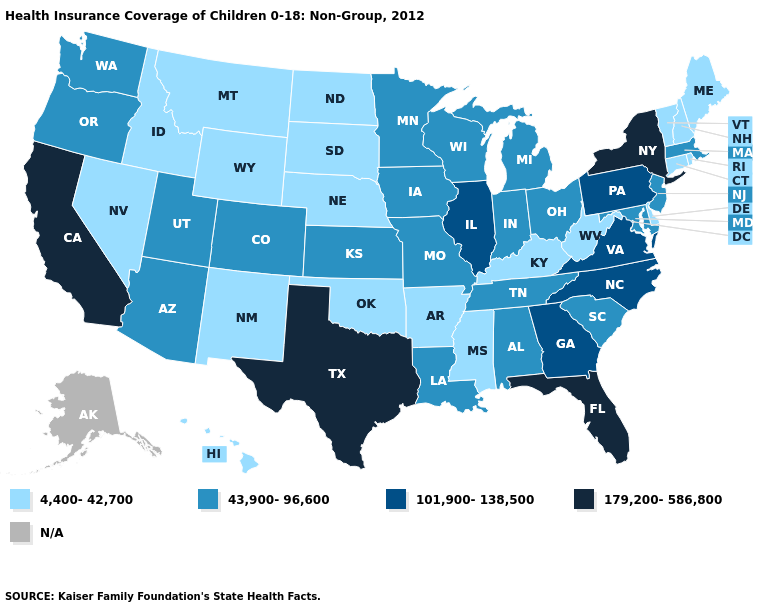Name the states that have a value in the range 4,400-42,700?
Short answer required. Arkansas, Connecticut, Delaware, Hawaii, Idaho, Kentucky, Maine, Mississippi, Montana, Nebraska, Nevada, New Hampshire, New Mexico, North Dakota, Oklahoma, Rhode Island, South Dakota, Vermont, West Virginia, Wyoming. Name the states that have a value in the range 43,900-96,600?
Concise answer only. Alabama, Arizona, Colorado, Indiana, Iowa, Kansas, Louisiana, Maryland, Massachusetts, Michigan, Minnesota, Missouri, New Jersey, Ohio, Oregon, South Carolina, Tennessee, Utah, Washington, Wisconsin. Which states hav the highest value in the Northeast?
Write a very short answer. New York. What is the lowest value in the USA?
Keep it brief. 4,400-42,700. What is the lowest value in the South?
Write a very short answer. 4,400-42,700. Name the states that have a value in the range 4,400-42,700?
Be succinct. Arkansas, Connecticut, Delaware, Hawaii, Idaho, Kentucky, Maine, Mississippi, Montana, Nebraska, Nevada, New Hampshire, New Mexico, North Dakota, Oklahoma, Rhode Island, South Dakota, Vermont, West Virginia, Wyoming. Name the states that have a value in the range 101,900-138,500?
Write a very short answer. Georgia, Illinois, North Carolina, Pennsylvania, Virginia. Is the legend a continuous bar?
Give a very brief answer. No. Does the map have missing data?
Write a very short answer. Yes. Name the states that have a value in the range 43,900-96,600?
Short answer required. Alabama, Arizona, Colorado, Indiana, Iowa, Kansas, Louisiana, Maryland, Massachusetts, Michigan, Minnesota, Missouri, New Jersey, Ohio, Oregon, South Carolina, Tennessee, Utah, Washington, Wisconsin. Name the states that have a value in the range 43,900-96,600?
Be succinct. Alabama, Arizona, Colorado, Indiana, Iowa, Kansas, Louisiana, Maryland, Massachusetts, Michigan, Minnesota, Missouri, New Jersey, Ohio, Oregon, South Carolina, Tennessee, Utah, Washington, Wisconsin. What is the lowest value in the USA?
Keep it brief. 4,400-42,700. Which states have the lowest value in the Northeast?
Concise answer only. Connecticut, Maine, New Hampshire, Rhode Island, Vermont. 